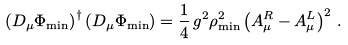<formula> <loc_0><loc_0><loc_500><loc_500>\left ( D _ { \mu } \Phi _ { \min } \right ) ^ { \dagger } \left ( D _ { \mu } \Phi _ { \min } \right ) = \frac { 1 } { 4 } \, g ^ { 2 } \rho _ { \min } ^ { 2 } \left ( A ^ { R } _ { \mu } - A ^ { L } _ { \mu } \right ) ^ { 2 } \, .</formula> 